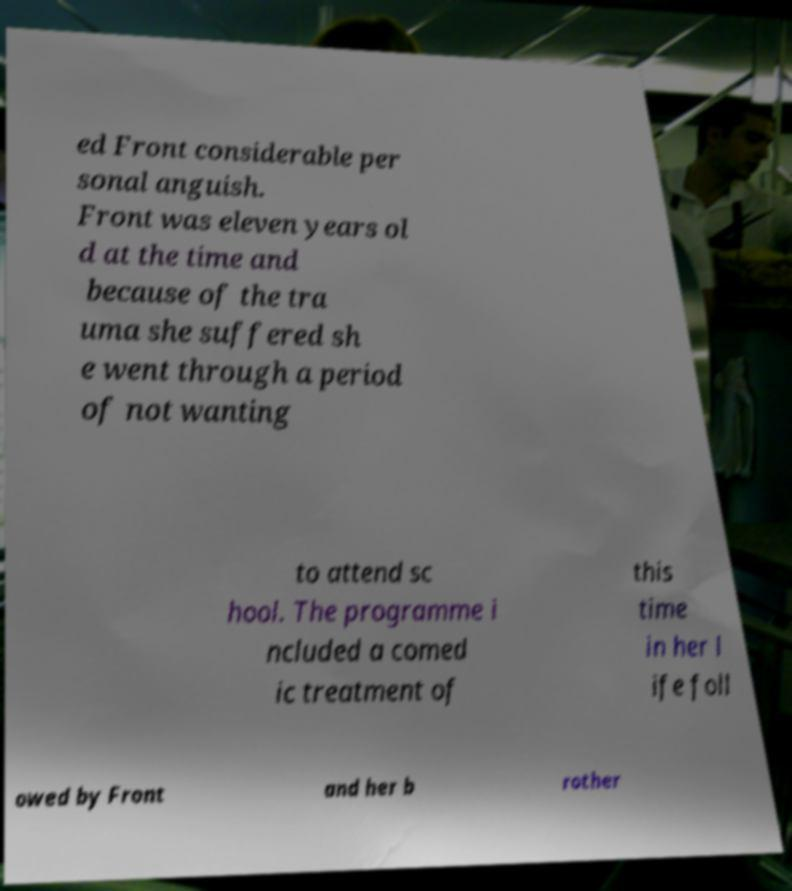Could you assist in decoding the text presented in this image and type it out clearly? ed Front considerable per sonal anguish. Front was eleven years ol d at the time and because of the tra uma she suffered sh e went through a period of not wanting to attend sc hool. The programme i ncluded a comed ic treatment of this time in her l ife foll owed by Front and her b rother 